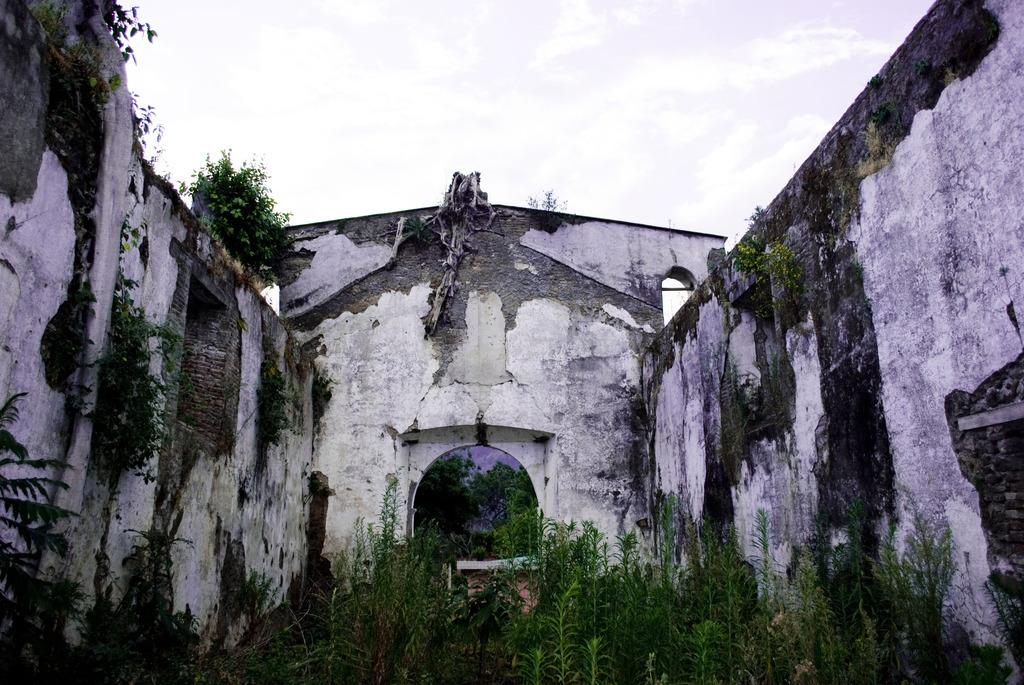What is the main subject in the center of the image? There is an old building in the center of the image. What can be seen at the bottom of the image? There are plants at the bottom of the image. What type of caption is written on the old building in the image? There is no caption visible on the old building in the image. What emotion is being expressed by the plants at the bottom of the image? Plants do not express emotions, so this question cannot be answered. 